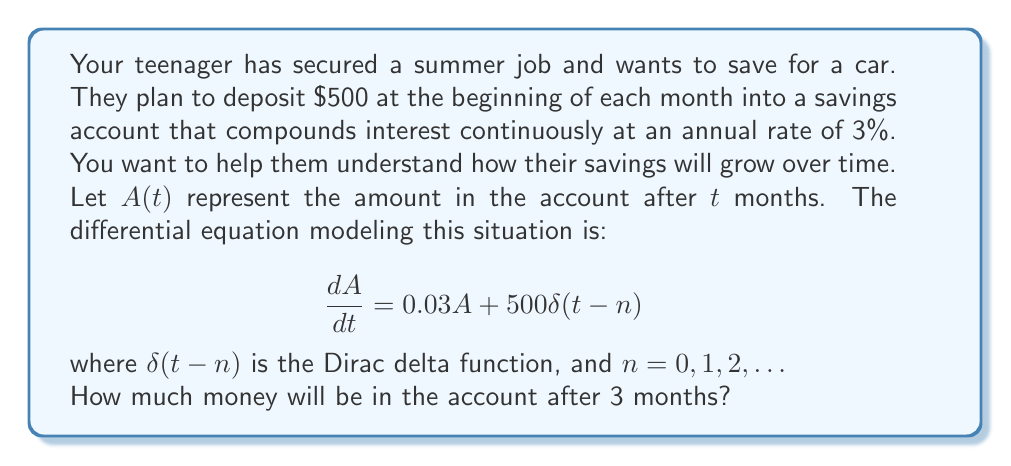Solve this math problem. To solve this problem, we'll follow these steps:

1) First, we need to solve the homogeneous part of the differential equation:
   $$\frac{dA}{dt} = 0.03A$$
   The solution to this is $A(t) = Ce^{0.03t}$, where $C$ is a constant.

2) Now, we need to account for the monthly deposits. Each deposit can be treated as an initial condition for the next month.

3) For the first month (0 ≤ t < 1):
   $A(0) = 500$, so $C = 500$
   $A(t) = 500e^{0.03t}$

4) At t = 1, we add another $500:
   $A(1) = 500e^{0.03} + 500 = 500(e^{0.03} + 1)$

5) For the second month (1 ≤ t < 2):
   $A(t) = 500(e^{0.03} + 1)e^{0.03(t-1)}$

6) At t = 2, we add another $500:
   $A(2) = 500(e^{0.03} + 1)e^{0.03} + 500 = 500(e^{0.06} + e^{0.03} + 1)$

7) For the third month (2 ≤ t < 3):
   $A(t) = 500(e^{0.06} + e^{0.03} + 1)e^{0.03(t-2)}$

8) At t = 3, which is what we're asked for:
   $A(3) = 500(e^{0.06} + e^{0.03} + 1)e^{0.03} + 500$
         $= 500(e^{0.09} + e^{0.06} + e^{0.03} + 1)$

9) Calculate the result:
   $A(3) = 500(1.09417 + 1.06184 + 1.03045 + 1)$
         $= 500 * 4.18646$
         $= 2093.23$

Therefore, after 3 months, there will be $2093.23 in the account.
Answer: $2093.23 